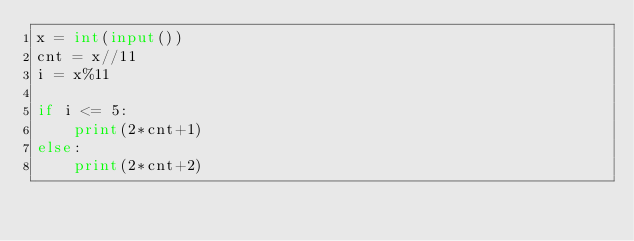Convert code to text. <code><loc_0><loc_0><loc_500><loc_500><_Python_>x = int(input())
cnt = x//11
i = x%11

if i <= 5:
    print(2*cnt+1)
else:
    print(2*cnt+2)</code> 